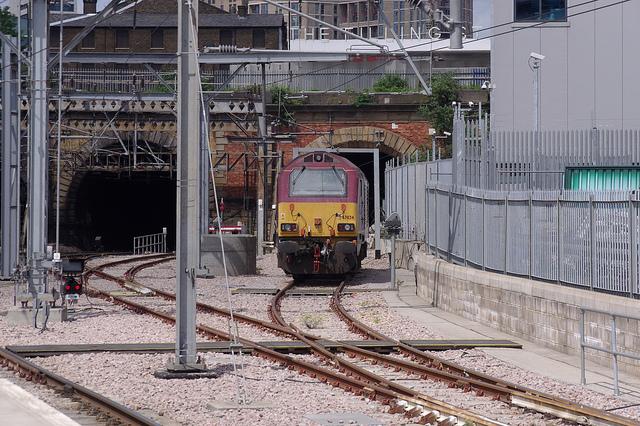Can you see a reflection?
Write a very short answer. No. Is this area off limits to the public?
Quick response, please. Yes. Is the train going through a tunnel?
Concise answer only. Yes. Is the train moving toward the camera?
Short answer required. Yes. Is the sky visible?
Write a very short answer. No. 